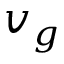Convert formula to latex. <formula><loc_0><loc_0><loc_500><loc_500>v _ { g }</formula> 